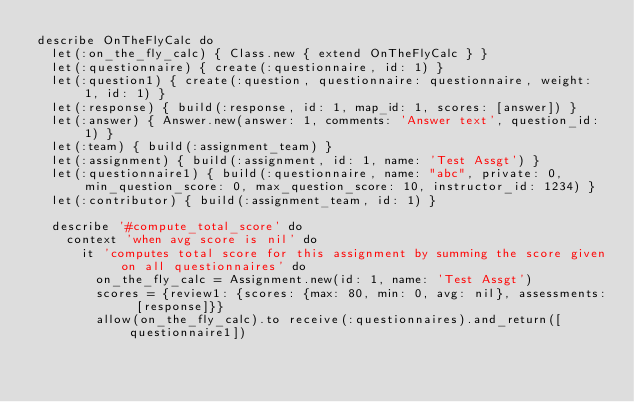Convert code to text. <code><loc_0><loc_0><loc_500><loc_500><_Ruby_>describe OnTheFlyCalc do
  let(:on_the_fly_calc) { Class.new { extend OnTheFlyCalc } }
  let(:questionnaire) { create(:questionnaire, id: 1) }
  let(:question1) { create(:question, questionnaire: questionnaire, weight: 1, id: 1) }
  let(:response) { build(:response, id: 1, map_id: 1, scores: [answer]) }
  let(:answer) { Answer.new(answer: 1, comments: 'Answer text', question_id: 1) }
  let(:team) { build(:assignment_team) }
  let(:assignment) { build(:assignment, id: 1, name: 'Test Assgt') }
  let(:questionnaire1) { build(:questionnaire, name: "abc", private: 0, min_question_score: 0, max_question_score: 10, instructor_id: 1234) }
  let(:contributor) { build(:assignment_team, id: 1) }

  describe '#compute_total_score' do
    context 'when avg score is nil' do
      it 'computes total score for this assignment by summing the score given on all questionnaires' do
        on_the_fly_calc = Assignment.new(id: 1, name: 'Test Assgt')
        scores = {review1: {scores: {max: 80, min: 0, avg: nil}, assessments: [response]}}
        allow(on_the_fly_calc).to receive(:questionnaires).and_return([questionnaire1])</code> 